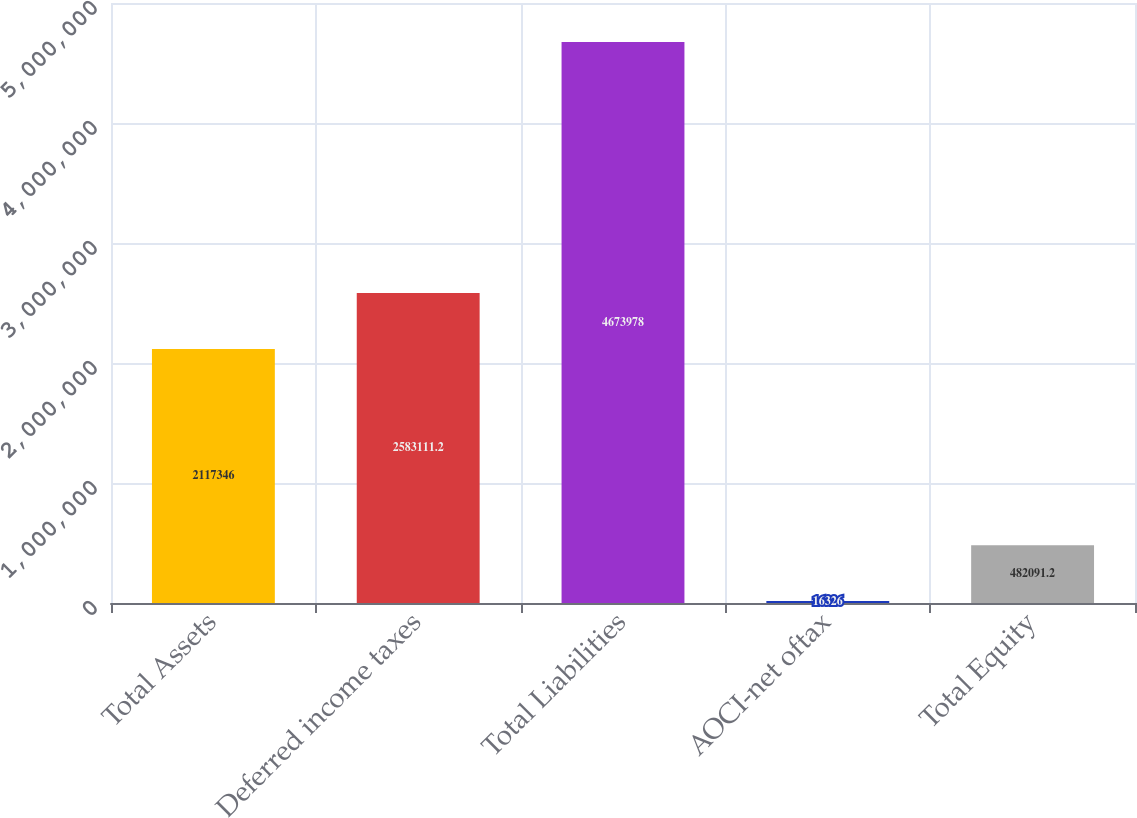<chart> <loc_0><loc_0><loc_500><loc_500><bar_chart><fcel>Total Assets<fcel>Deferred income taxes<fcel>Total Liabilities<fcel>AOCI-net oftax<fcel>Total Equity<nl><fcel>2.11735e+06<fcel>2.58311e+06<fcel>4.67398e+06<fcel>16326<fcel>482091<nl></chart> 